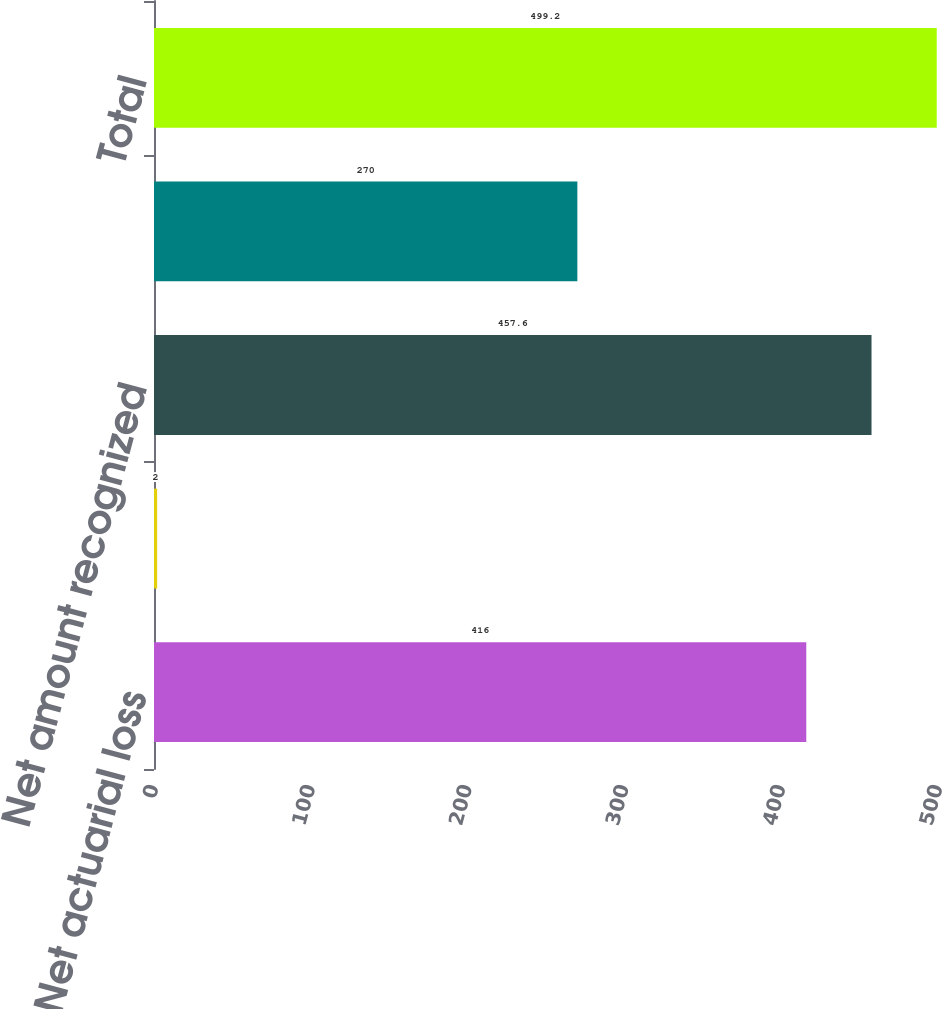Convert chart to OTSL. <chart><loc_0><loc_0><loc_500><loc_500><bar_chart><fcel>Net actuarial loss<fcel>Prior service cost (credit)<fcel>Net amount recognized<fcel>Regulatory assets<fcel>Total<nl><fcel>416<fcel>2<fcel>457.6<fcel>270<fcel>499.2<nl></chart> 